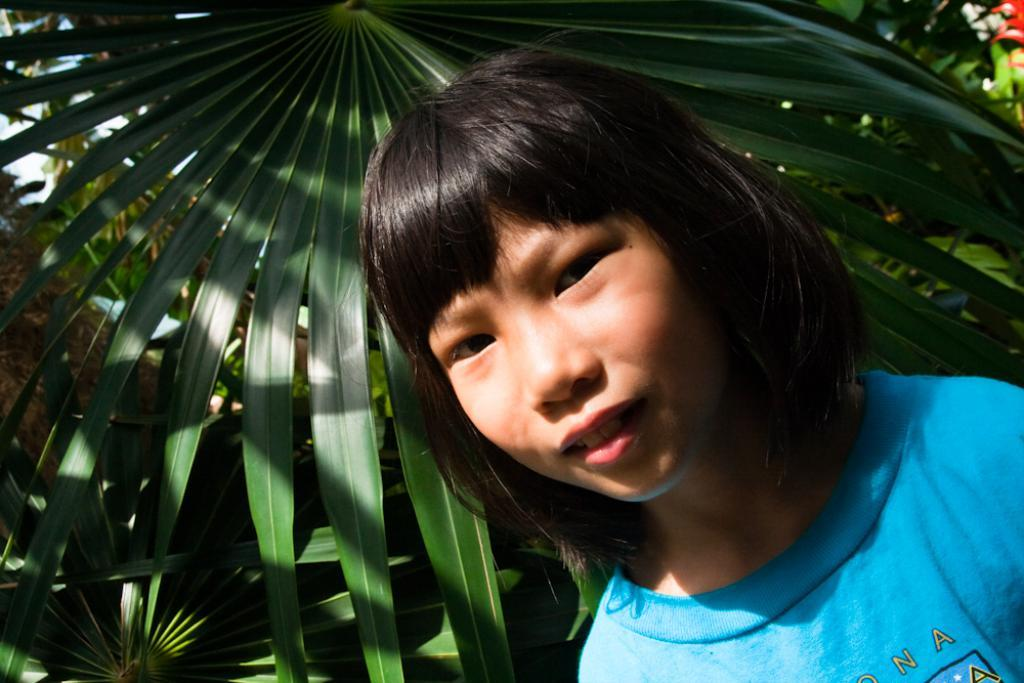Who or what is the main subject of the image? There is a person in the image. What is the person wearing? The person is wearing a blue shirt. What can be seen in the background of the image? There are trees in the background of the image. What is the color of the trees? The trees are green. What else is visible in the image? The sky is visible in the image. What colors can be seen in the sky? The sky is blue and white. What organization is responsible for the maintenance of the trees in the image? There is no information about an organization responsible for the maintenance of the trees in the image. What place is depicted in the image? The image does not depict a specific place; it only shows a person, trees, and the sky. 